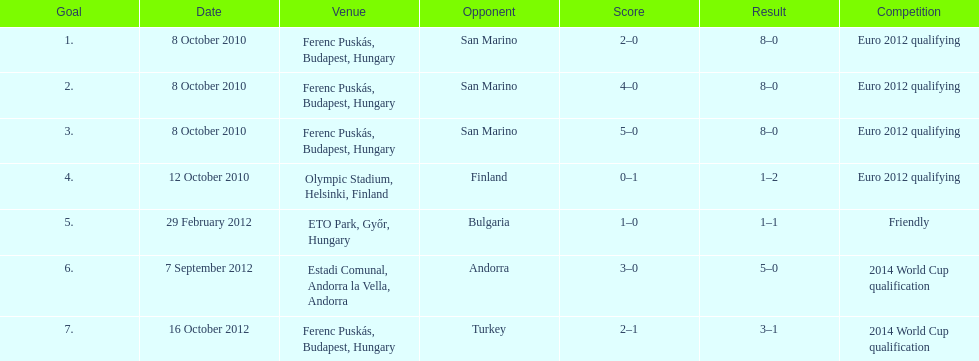When did ádám szalai achieve his first international goal? 8 October 2010. 